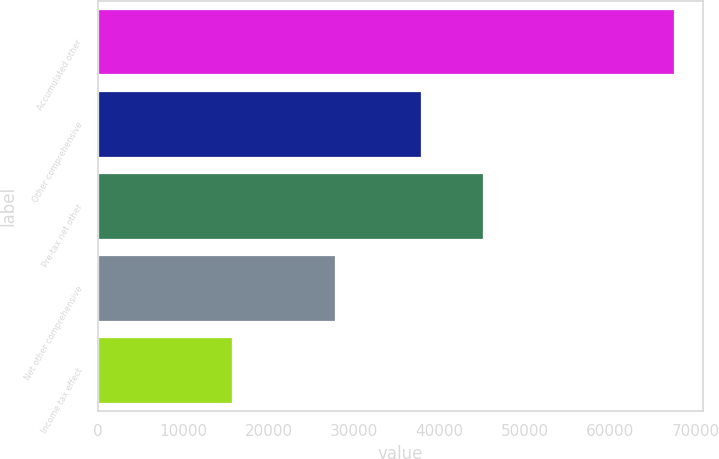Convert chart to OTSL. <chart><loc_0><loc_0><loc_500><loc_500><bar_chart><fcel>Accumulated other<fcel>Other comprehensive<fcel>Pre-tax net other<fcel>Net other comprehensive<fcel>Income tax effect<nl><fcel>67426.6<fcel>37853<fcel>45078.6<fcel>27771<fcel>15716<nl></chart> 